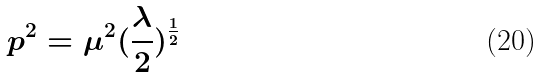Convert formula to latex. <formula><loc_0><loc_0><loc_500><loc_500>p ^ { 2 } = \mu ^ { 2 } ( \frac { \lambda } { 2 } ) ^ { \frac { 1 } { 2 } }</formula> 